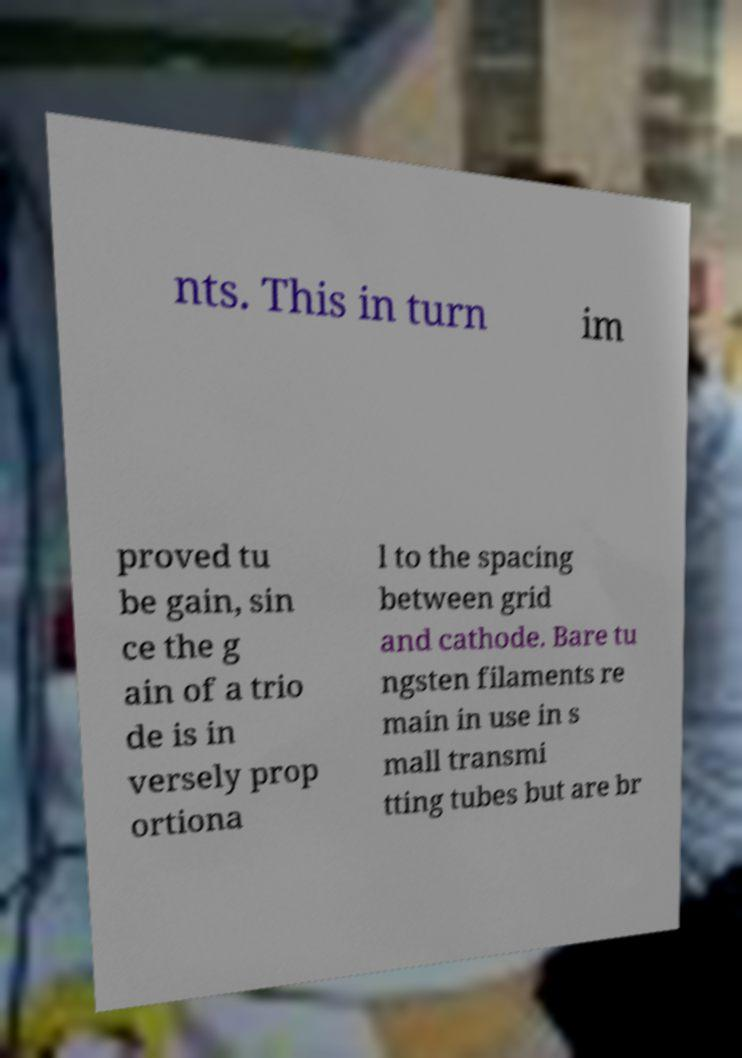There's text embedded in this image that I need extracted. Can you transcribe it verbatim? nts. This in turn im proved tu be gain, sin ce the g ain of a trio de is in versely prop ortiona l to the spacing between grid and cathode. Bare tu ngsten filaments re main in use in s mall transmi tting tubes but are br 